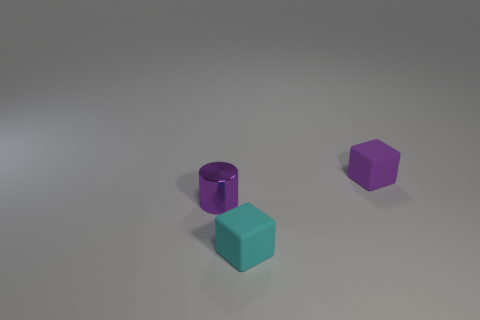Add 1 blocks. How many objects exist? 4 Subtract all cylinders. How many objects are left? 2 Subtract 0 yellow balls. How many objects are left? 3 Subtract all blue cylinders. Subtract all metal cylinders. How many objects are left? 2 Add 1 rubber things. How many rubber things are left? 3 Add 3 purple cylinders. How many purple cylinders exist? 4 